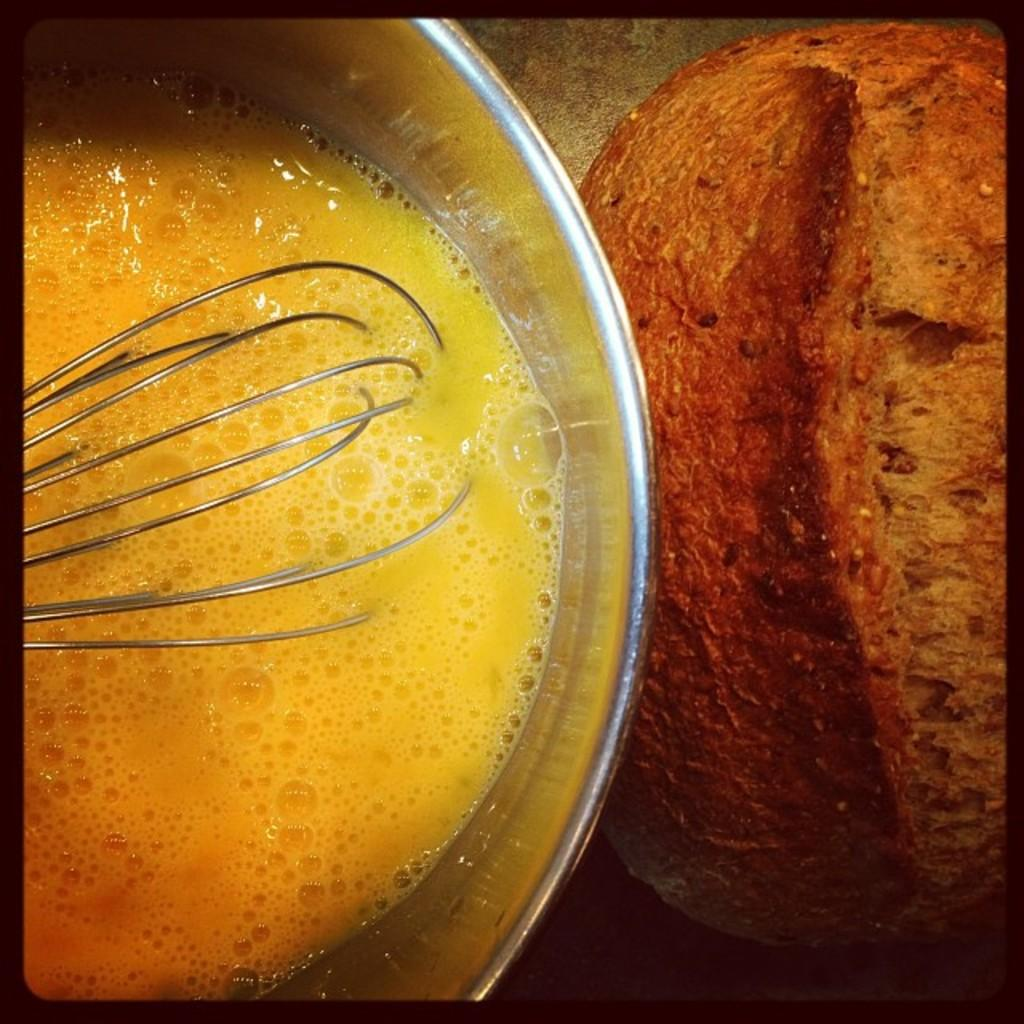What is in the bowl that is visible in the image? There is a bowl containing smoothie in the image. What tool is used to blend the smoothie in the image? A hand blender is visible in the image. What other edible item can be seen on the table in the image? There is an edible item on the table in the image, but the specific item is not mentioned in the facts. What is the smell of the smoothie in the image? The facts provided do not mention any information about the smell of the smoothie, so it cannot be determined from the image. 